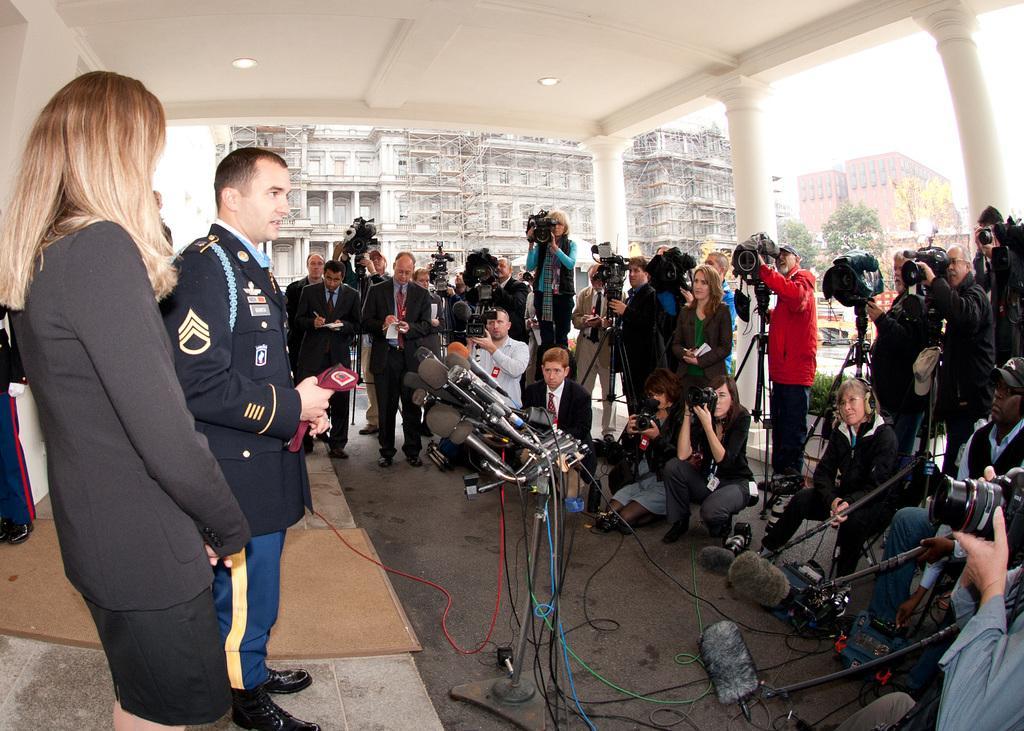How would you summarize this image in a sentence or two? On the left there are mice, a person in uniform and a woman standing. On the right there are cameras, people, chairs, microphones, bags and other objects. In the center of the picture there are cameras, stands and people. In the background there are buildings, trees and other object. 